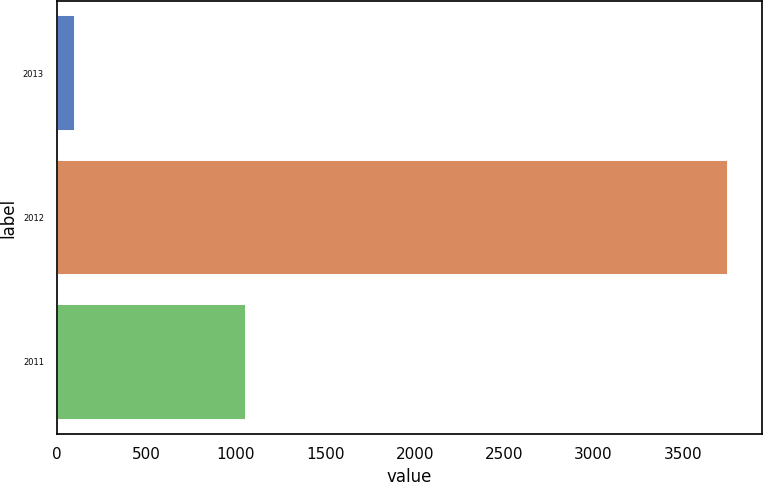<chart> <loc_0><loc_0><loc_500><loc_500><bar_chart><fcel>2013<fcel>2012<fcel>2011<nl><fcel>102<fcel>3754<fcel>1058<nl></chart> 